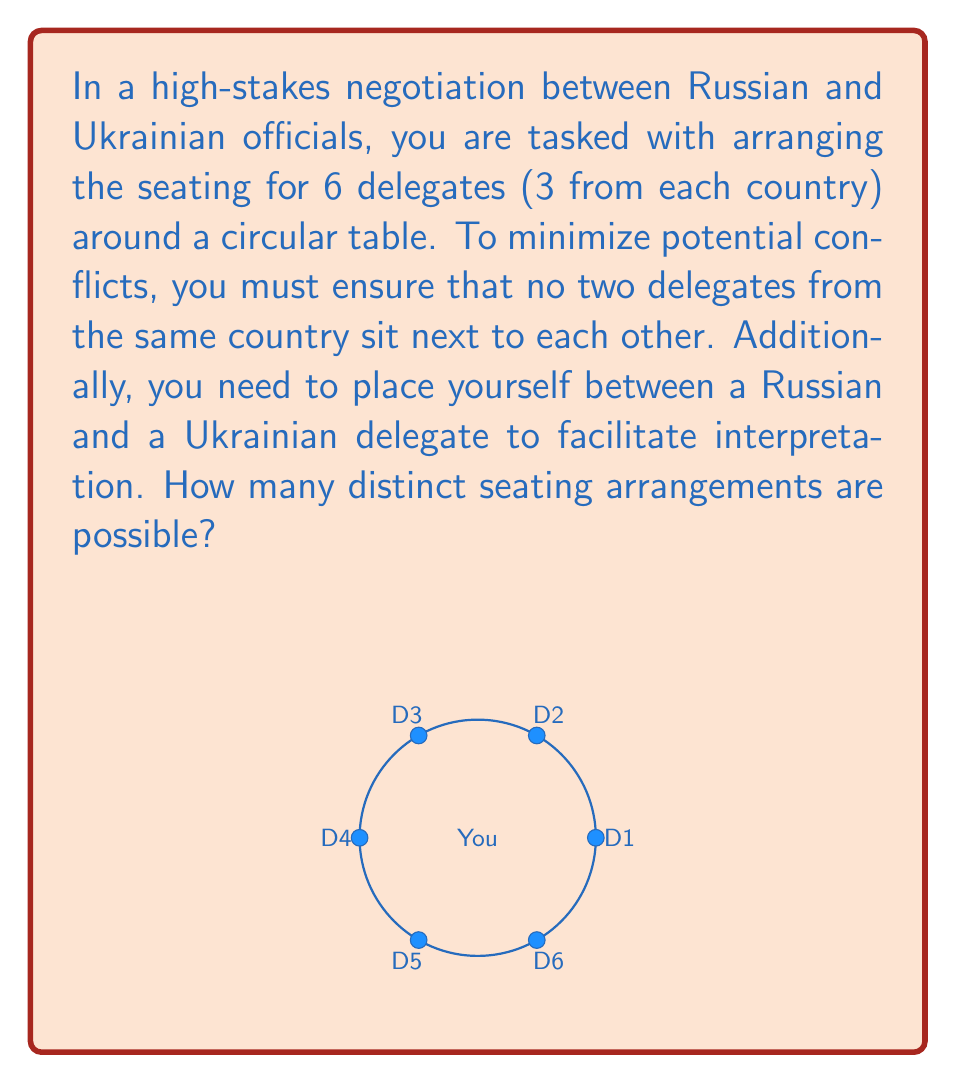What is the answer to this math problem? Let's approach this step-by-step using graph theory and combinatorics:

1) First, we need to arrange the delegates alternating between Russian and Ukrainian. This can be done in 2 ways (RURURU or URURUR).

2) For each of these arrangements, we need to consider the number of ways to permute the 3 Russian delegates (R1, R2, R3) and the 3 Ukrainian delegates (U1, U2, U3) among themselves.

3) The number of permutations for each country's delegates is 3! = 6.

4) Now, we need to consider your position. You can sit between any Russian-Ukrainian pair, and there are 3 such pairs in each arrangement.

5) Let's put this together:
   - 2 ways to alternate countries
   - 6 ways to arrange Russian delegates
   - 6 ways to arrange Ukrainian delegates
   - 3 positions for you to sit

6) Using the multiplication principle, the total number of arrangements is:

   $$ 2 \times 6 \times 6 \times 3 = 216 $$

Therefore, there are 216 distinct seating arrangements possible.
Answer: 216 